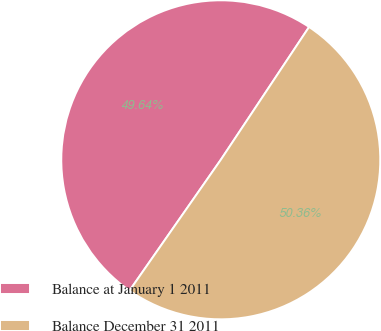Convert chart to OTSL. <chart><loc_0><loc_0><loc_500><loc_500><pie_chart><fcel>Balance at January 1 2011<fcel>Balance December 31 2011<nl><fcel>49.64%<fcel>50.36%<nl></chart> 